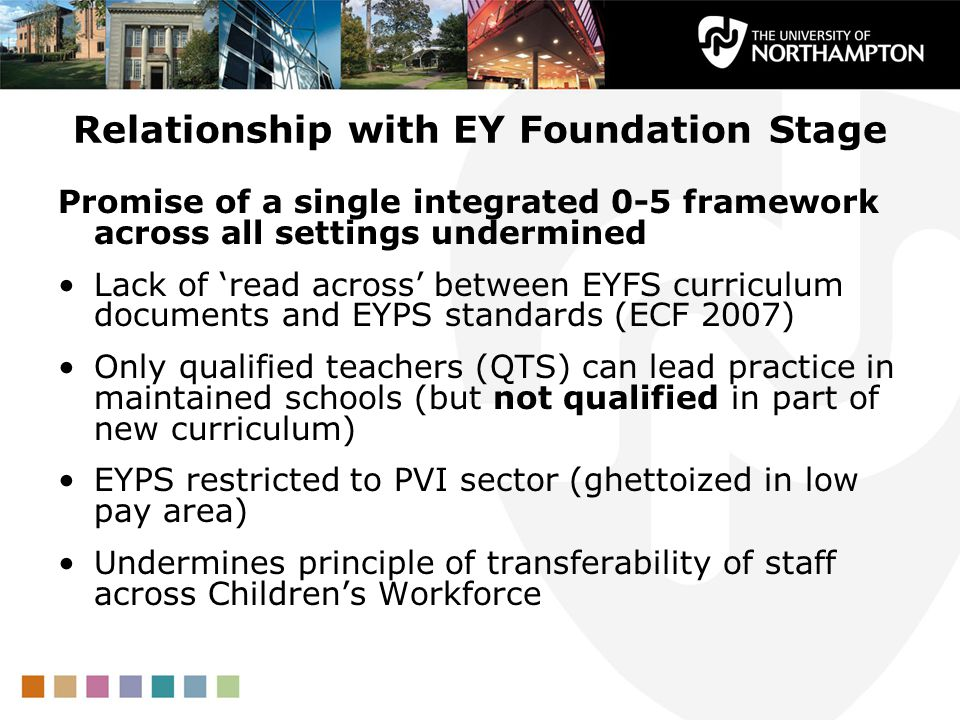Can these implications for staff mobility and educational quality affect the overall perception of the EYFS framework? If so, in what way? Indeed, the implications for staff mobility and educational quality can significantly affect the overall perception of the EYFS framework. If the framework is seen as inconsistent and unable to provide a uniform standard of education across different settings, it may lose credibility among educators and parents. The perception that the framework lacks coherence and fails to support professional growth and equitable pay can lead to challenges in attracting and retaining skilled educators. Furthermore, if inequities persist between different sectors, parents might question the quality and value of early years education provided under the EYFS framework. This could result in decreased trust and support for the framework, ultimately impacting its effectiveness and implementation. 